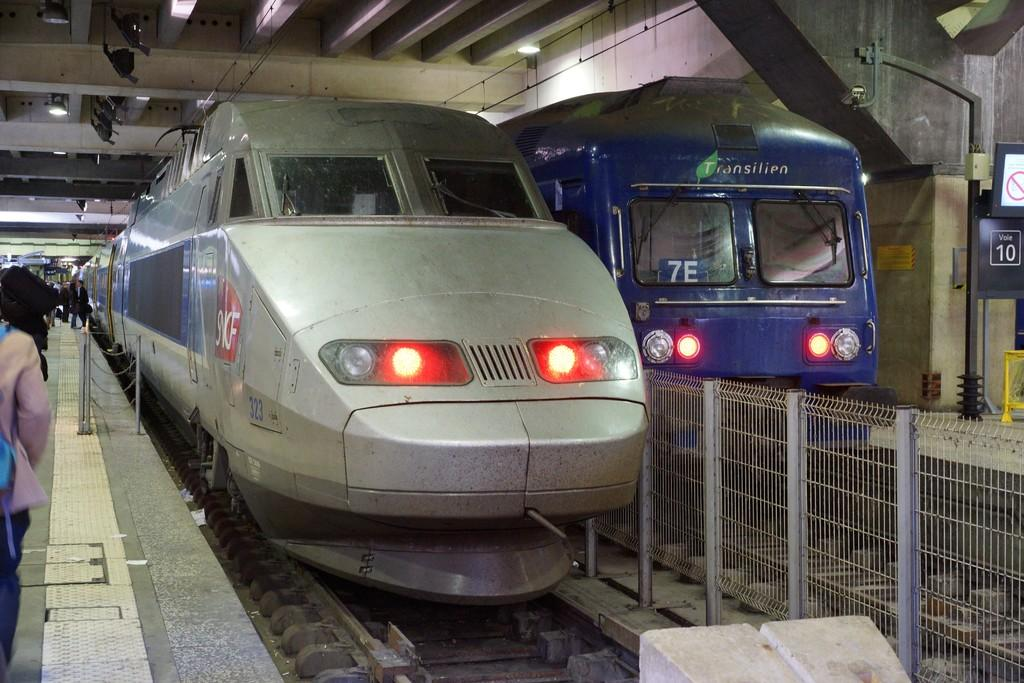<image>
Offer a succinct explanation of the picture presented. a couple trains with one that has the letters 7E on it 